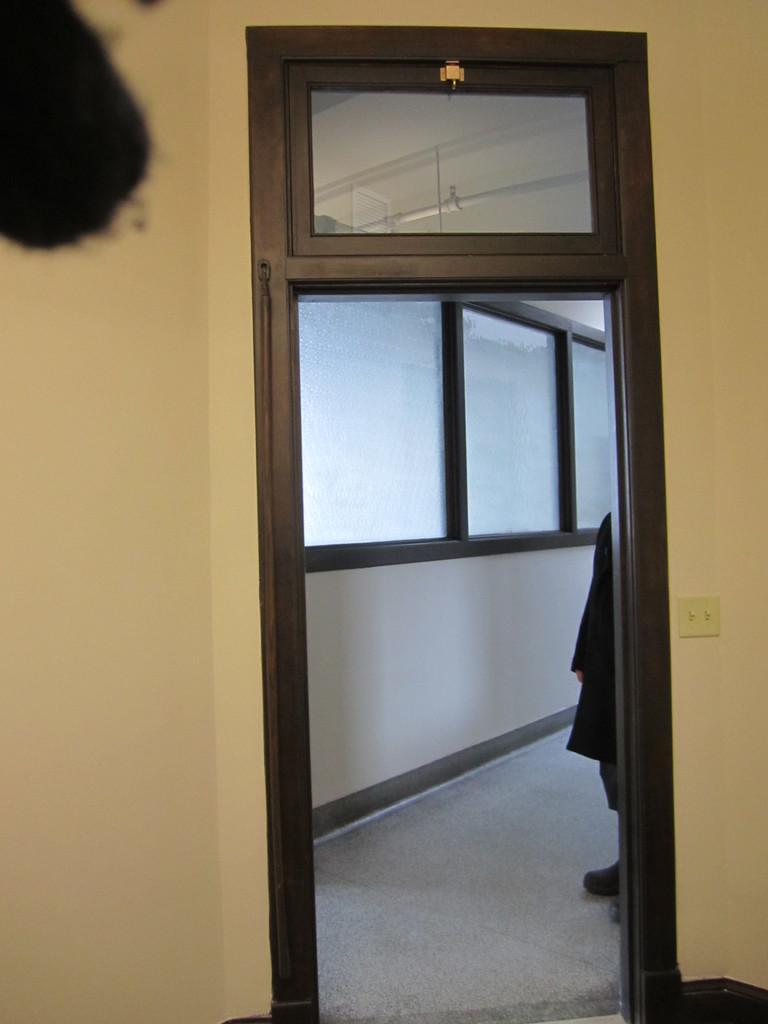In one or two sentences, can you explain what this image depicts? This is an inside view. In the middle of the image there is a door. Behind there is a person standing. In the background there is a glass window. In the top left-hand corner there is an object. 